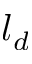Convert formula to latex. <formula><loc_0><loc_0><loc_500><loc_500>l _ { d }</formula> 